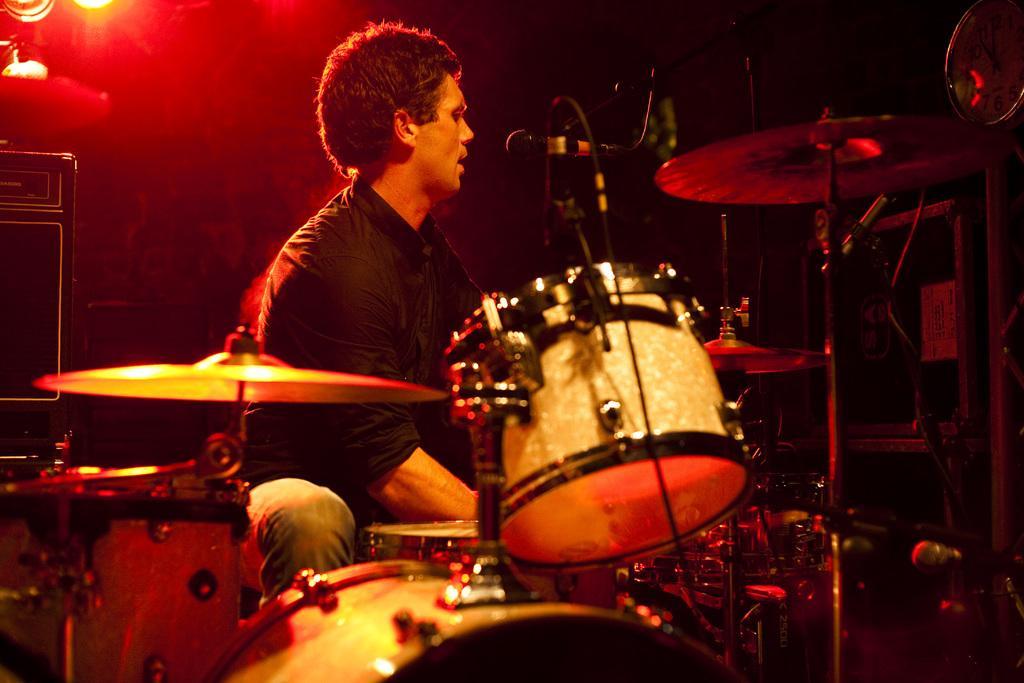How would you summarize this image in a sentence or two? In this image there is a person playing a musical instrument, there is a stand, there is a microphone, there is a speaker towardś the left of the image, there is a wall clock towardś the right of the image, there is a light, there is a wire. 